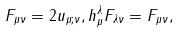<formula> <loc_0><loc_0><loc_500><loc_500>F _ { \mu \nu } = 2 u _ { \mu ; \nu } , h ^ { \lambda } _ { \mu } F _ { \lambda \nu } = F _ { \mu \nu } ,</formula> 